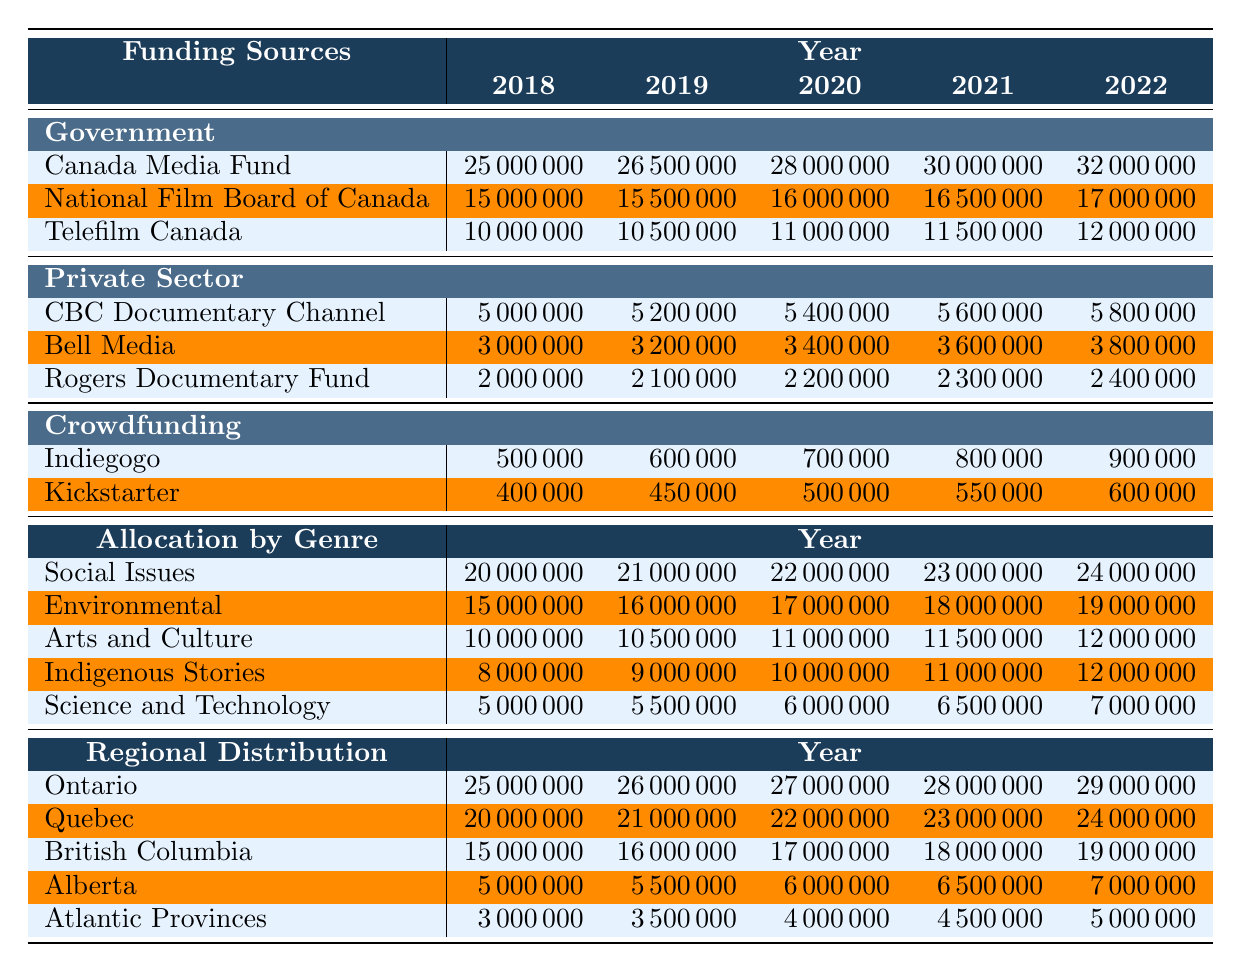What was the total funding from the Canada Media Fund in 2021? Looking at the "Government" funding sources, the Canada Media Fund had a value of 30000000 in 2021.
Answer: 30000000 What is the difference in funding from Telefilm Canada between 2018 and 2022? The funding from Telefilm Canada in 2018 was 10000000, and in 2022 it increased to 12000000. The difference is 12000000 - 10000000 = 2000000.
Answer: 2000000 Did funding from the CBC Documentary Channel increase every year from 2018 to 2022? The funding from CBC Documentary Channel increased from 5000000 in 2018 to 5800000 in 2022 for each year.
Answer: Yes What is the average amount of funding for Indigenous Stories over the years 2018 to 2022? The values for Indigenous Stories from 2018 to 2022 are 8000000, 9000000, 10000000, 11000000, and 12000000. The sum is 8000000 + 9000000 + 10000000 + 11000000 + 12000000 = 60000000 and dividing by 5 gives an average of 60000000 / 5 = 12000000.
Answer: 12000000 Which genre received the highest allocation in 2022? In the "Allocation by Genre" section for 2022, Social Issues had an allocation of 24000000, which is higher than other genres.
Answer: Social Issues What was the total funding for Arts and Culture from 2018 to 2022? The funding for Arts and Culture for 2018 to 2022 is 10000000, 10500000, 11000000, 11500000, and 12000000. The total is 10000000 + 10500000 + 11000000 + 11500000 + 12000000 = 55000000.
Answer: 55000000 How much more funding did Ontario receive compared to Alberta in 2021? In 2021, Ontario received 28000000 and Alberta received 6500000. The difference is 28000000 - 6500000 = 21500000.
Answer: 21500000 If we combine all crowdfunding from Indiegogo and Kickstarter in 2020, what would be the total? The funding from Indiegogo in 2020 is 700000 and from Kickstarter in 2020 is 500000. The total is 700000 + 500000 = 1200000.
Answer: 1200000 Which province had the least funding in 2019? Looking at the "Regional Distribution" for 2019, Atlantic Provinces received 3500000, which is less compared to other provinces.
Answer: Atlantic Provinces What is the trend in funding for the Environmental genre from 2018 to 2022? The funding for Environmental genre increased from 15000000 in 2018 to 19000000 in 2022, showing a consistent upward trend over the years.
Answer: Increasing What was the overall funding from the Government sources in 2020? The total funding from Government sources in 2020 is the sum of the individual contributions: 28000000 (Canada Media Fund) + 16000000 (National Film Board) + 11000000 (Telefilm Canada) = 55000000.
Answer: 55000000 